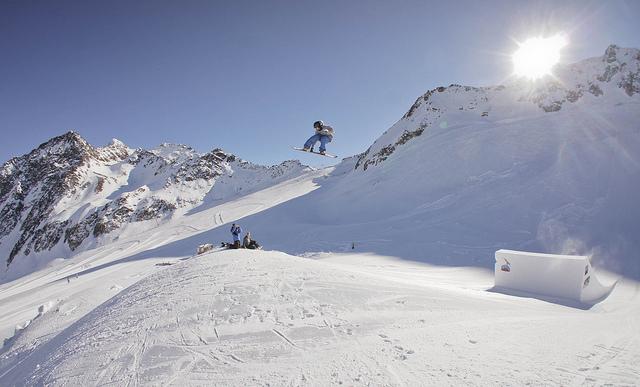Has this photo been altered?
Keep it brief. No. Is it winter?
Quick response, please. Yes. Can you see a ramp in the picture?
Be succinct. Yes. What is the person doing?
Quick response, please. Snowboarding. 